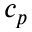<formula> <loc_0><loc_0><loc_500><loc_500>c _ { p }</formula> 